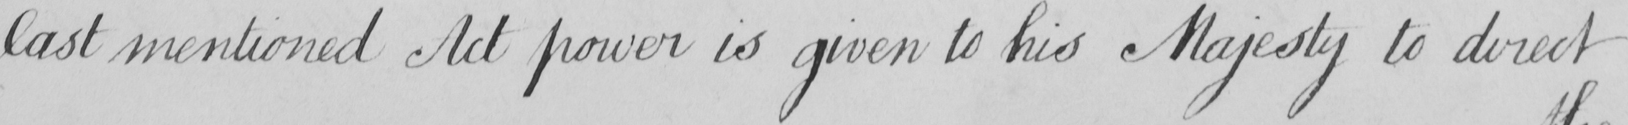Please transcribe the handwritten text in this image. last mentioned Act power is given to his Majesty to direct 